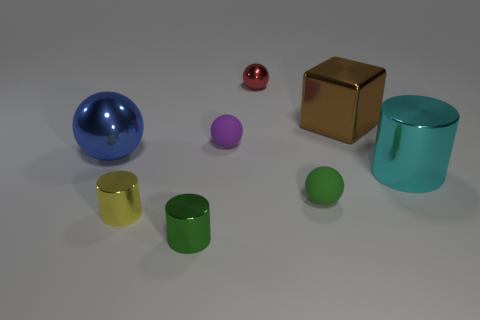Subtract all red spheres. How many spheres are left? 3 Add 2 tiny purple balls. How many objects exist? 10 Subtract all purple balls. How many balls are left? 3 Subtract 1 spheres. How many spheres are left? 3 Subtract all cylinders. How many objects are left? 5 Subtract all yellow spheres. Subtract all blue cylinders. How many spheres are left? 4 Subtract all small purple objects. Subtract all big metallic cylinders. How many objects are left? 6 Add 5 red spheres. How many red spheres are left? 6 Add 6 large cyan metal cylinders. How many large cyan metal cylinders exist? 7 Subtract 0 red cylinders. How many objects are left? 8 